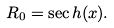Convert formula to latex. <formula><loc_0><loc_0><loc_500><loc_500>R _ { 0 } = \sec h ( x ) .</formula> 